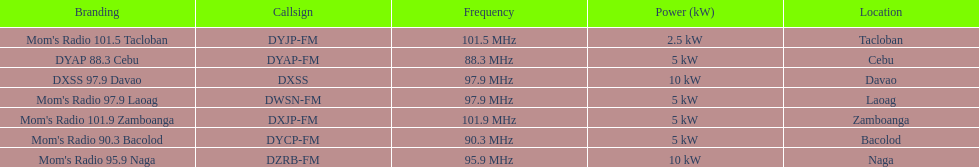What are the total number of radio stations on this list? 7. 